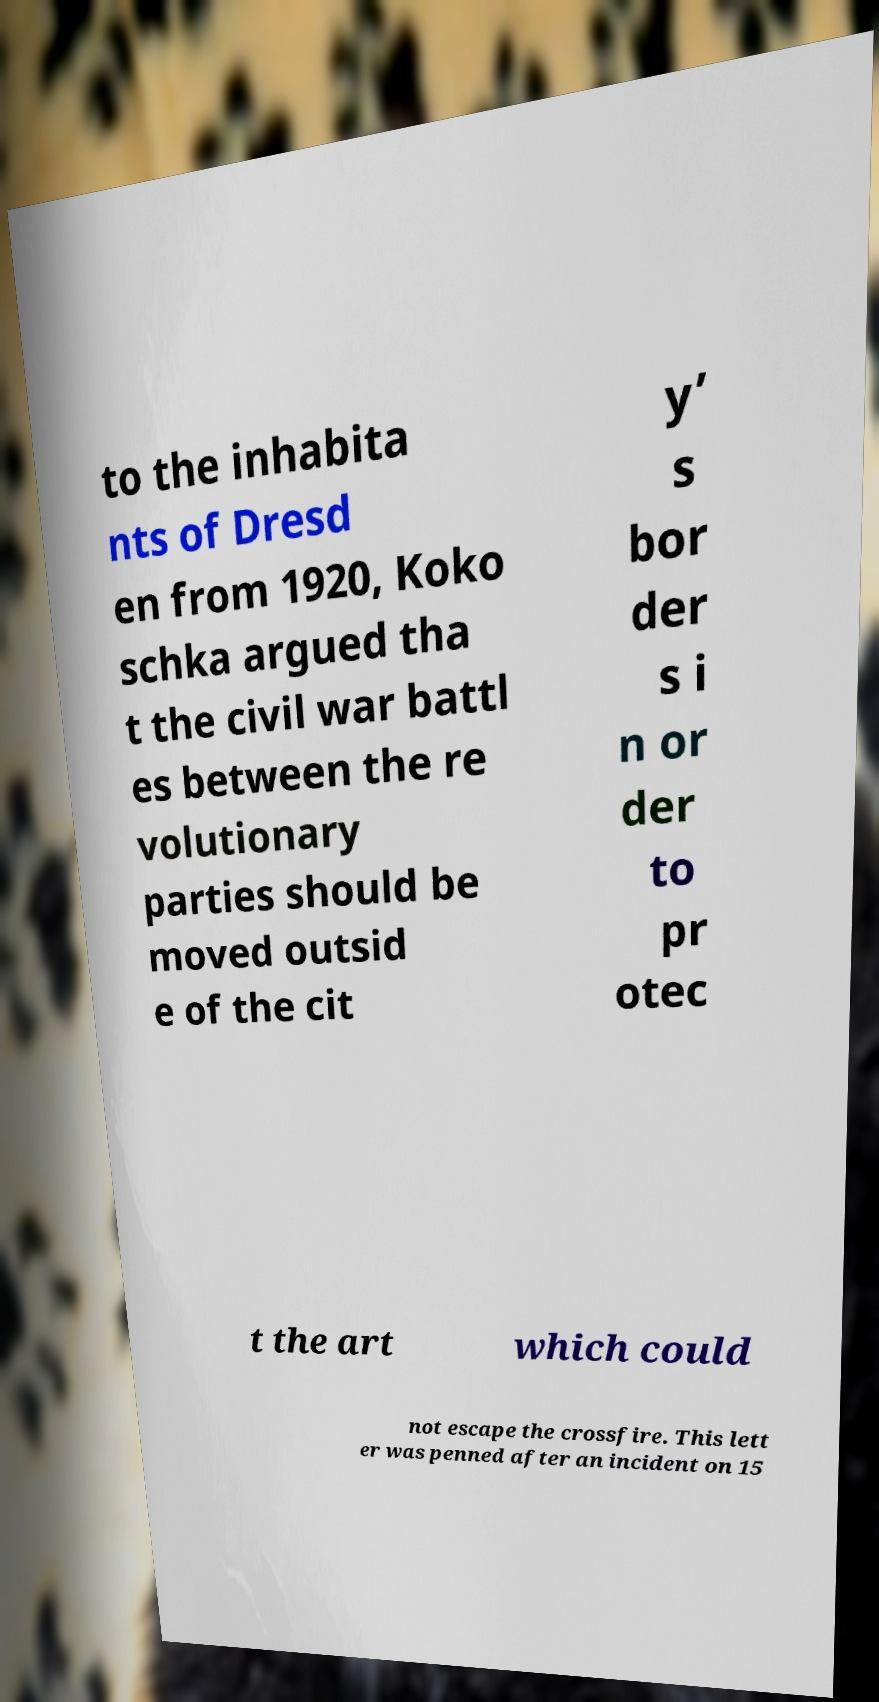Please read and relay the text visible in this image. What does it say? to the inhabita nts of Dresd en from 1920, Koko schka argued tha t the civil war battl es between the re volutionary parties should be moved outsid e of the cit y’ s bor der s i n or der to pr otec t the art which could not escape the crossfire. This lett er was penned after an incident on 15 